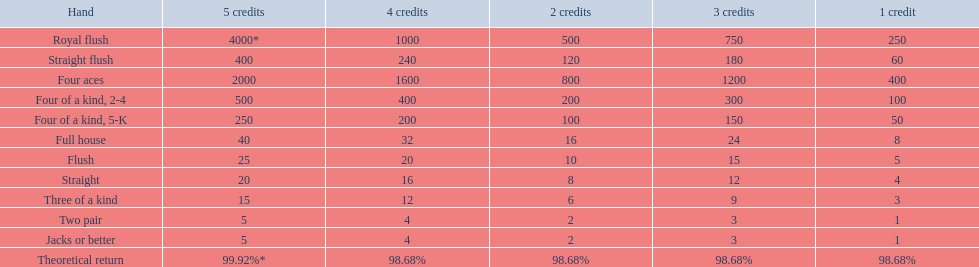The number of credits returned for a one credit bet on a royal flush are. 250. 